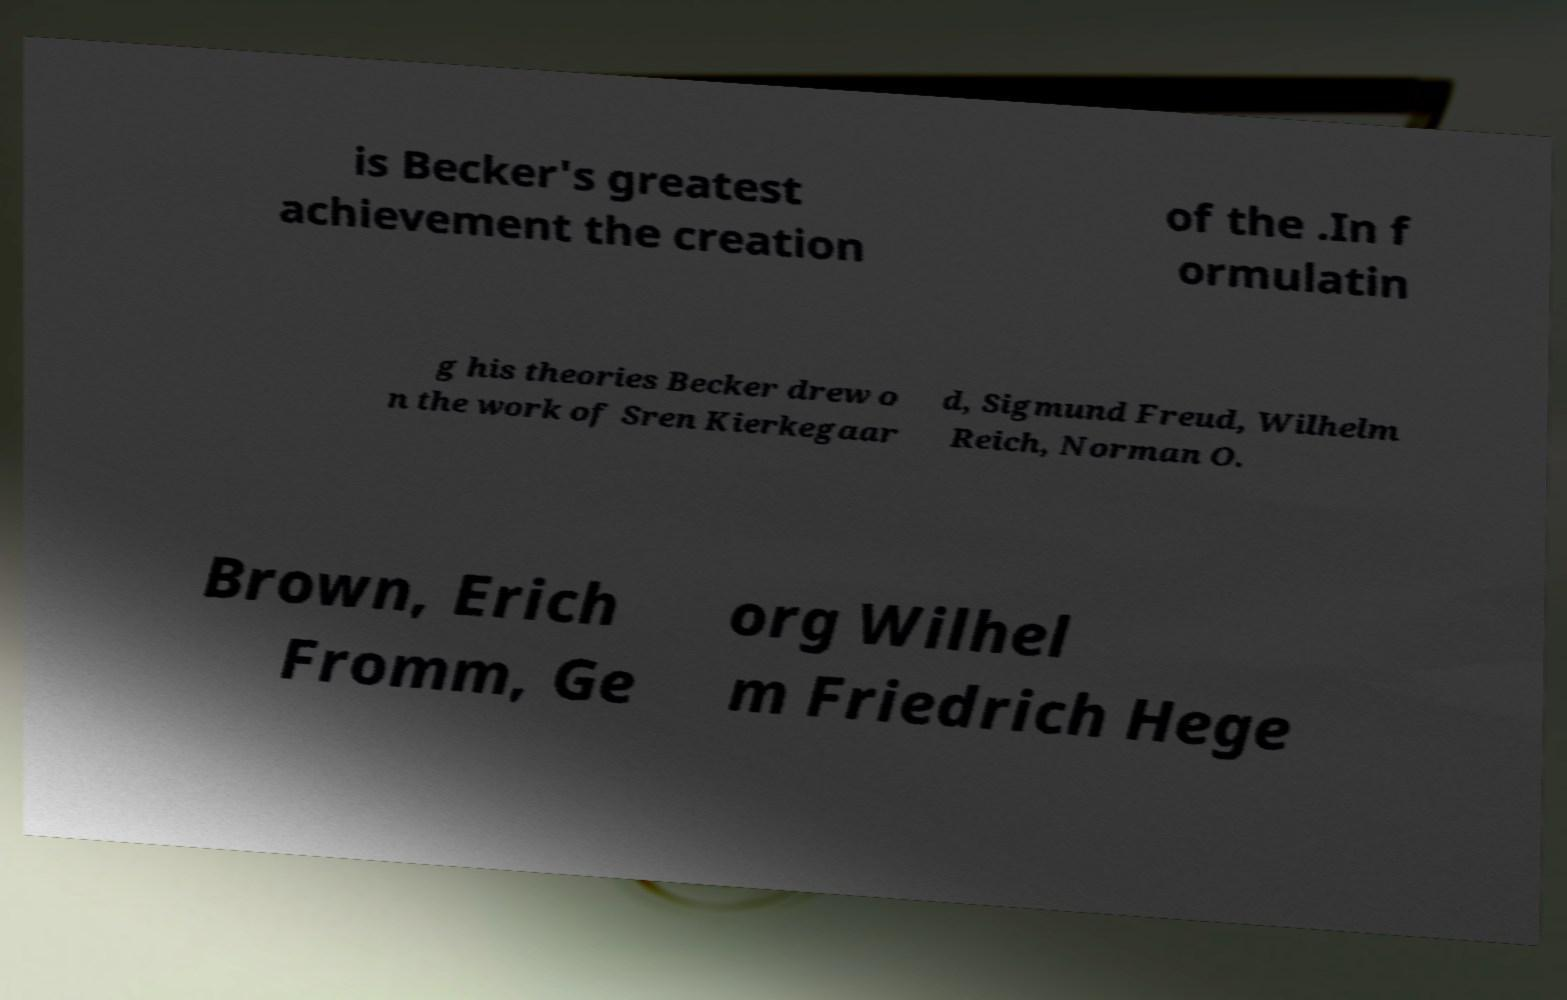Please identify and transcribe the text found in this image. is Becker's greatest achievement the creation of the .In f ormulatin g his theories Becker drew o n the work of Sren Kierkegaar d, Sigmund Freud, Wilhelm Reich, Norman O. Brown, Erich Fromm, Ge org Wilhel m Friedrich Hege 